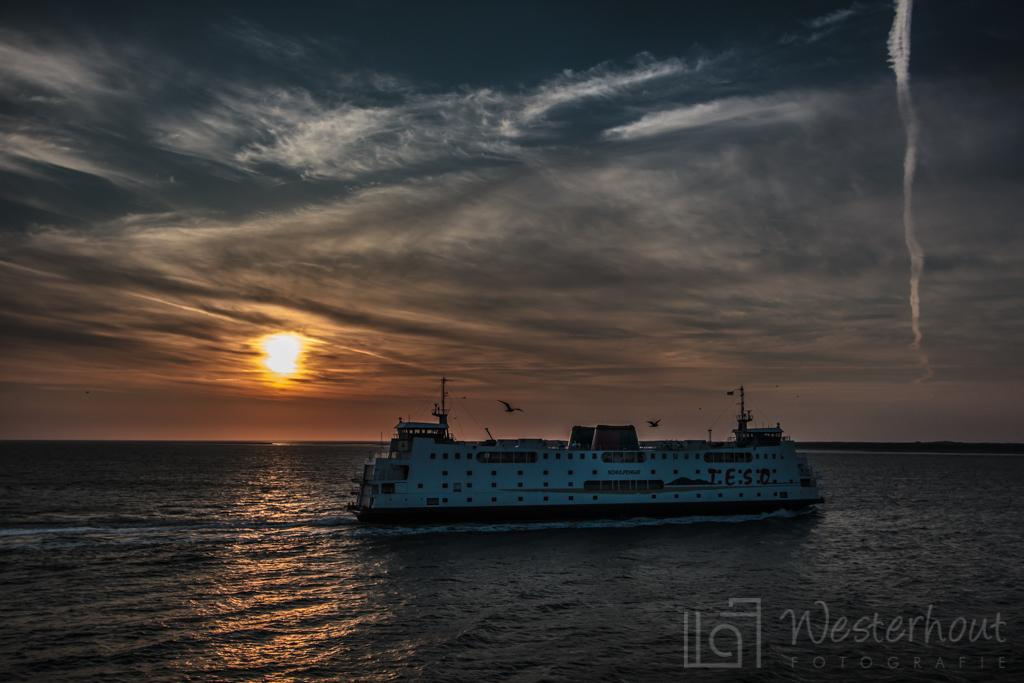What is the main subject of the image? The main subject of the image is a ship. Where is the ship located in the image? The ship is on the water surface in the image. What can be seen in the sky in the image? The sun is visible in the sky in the image. How many tents are set up on the ship in the image? There are no tents present on the ship in the image. What type of care is being provided to the ship in the image? There is no indication of any care being provided to the ship in the image. 